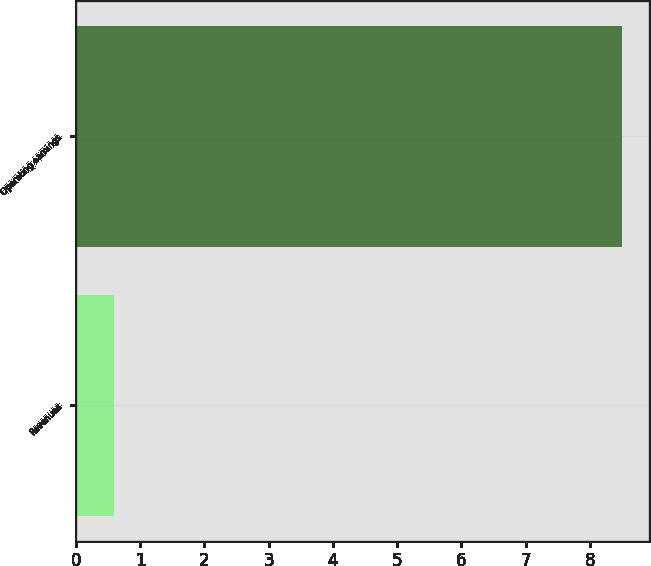Convert chart. <chart><loc_0><loc_0><loc_500><loc_500><bar_chart><fcel>Revenues<fcel>Operating earnings<nl><fcel>0.6<fcel>8.5<nl></chart> 